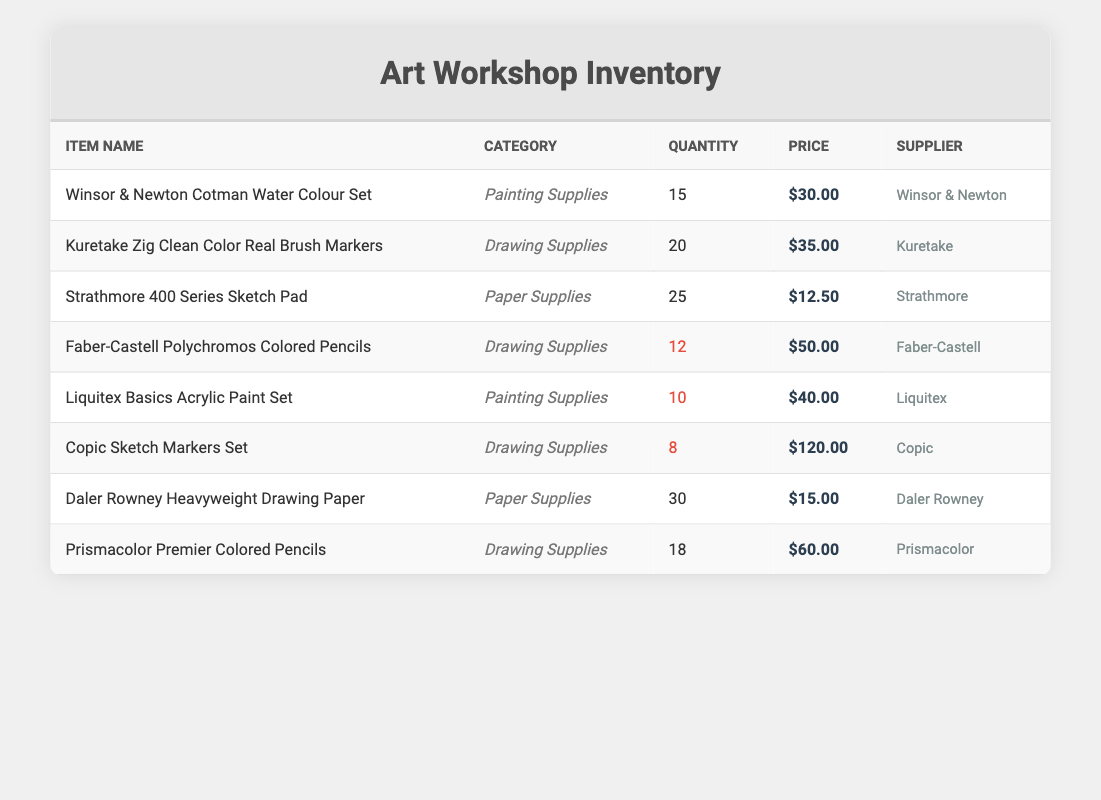What is the total quantity of drawing supplies available? To find the total quantity of drawing supplies, sum the quantities of all items in the "Drawing Supplies" category: Kuretake Zig Clean Color Real Brush Markers (20) + Faber-Castell Polychromos Colored Pencils (12) + Copic Sketch Markers Set (8) + Prismacolor Premier Colored Pencils (18) = 20 + 12 + 8 + 18 = 58
Answer: 58 Which item has the highest price per unit? Compare the price per unit of all items listed in the table. The prices are as follows: Water Colour Set (30.00), Brush Markers (35.00), Sketch Pad (12.50), Colored Pencils (50.00), Acrylic Paint Set (40.00), Sketch Markers Set (120.00), Drawing Paper (15.00), Premier Colored Pencils (60.00). The highest price is 120.00 for the Copic Sketch Markers Set.
Answer: Copic Sketch Markers Set Are there any items with low stock? Review the quantity column for indications. Items with a quantity of less than 10 would indicate low stock. From the table, the items with low stock are: Liquitex Basics Acrylic Paint Set (10), Copic Sketch Markers Set (8), and Faber-Castell Polychromos Colored Pencils (12). Therefore, yes, there are items with low stock.
Answer: Yes What is the average price of the painting supplies listed? Identify the prices for painting supplies: Winsor & Newton Cotman Water Colour Set (30.00) and Liquitex Basics Acrylic Paint Set (40.00). Sum these prices (30.00 + 40.00 = 70.00) and divide by the number of painting supplies, which is 2. Thus, the average price is 70.00 / 2 = 35.00.
Answer: 35.00 How many more drawing supplies than painting supplies are there? Count the number of items in each category. Drawing Supplies have 4 items (Kuretake Zig Clean Color Real Brush Markers, Faber-Castell Polychromos Colored Pencils, Copic Sketch Markers Set, Prismacolor Premier Colored Pencils), while Painting Supplies have 2 items (Winsor & Newton Cotman Water Colour Set, Liquitex Basics Acrylic Paint Set). The difference is 4 - 2 = 2.
Answer: 2 